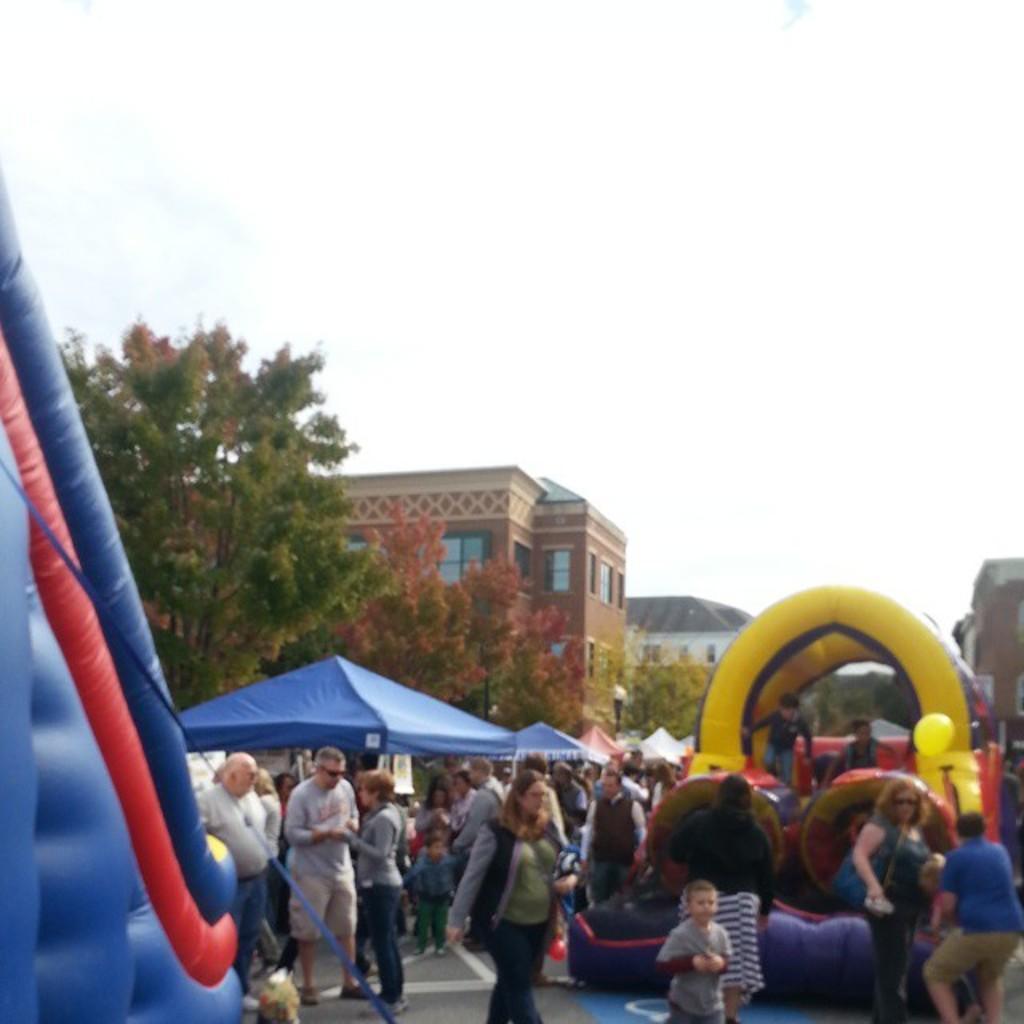Please provide a concise description of this image. In this image it looks like it is an exhibition in which there are so many tents, under which there are shops. There are so many people who are walking on the road while other are standing and talking with each other. On the left side there is a gas balloon. In the background there is a building. At the top there is the sky. On the left side there is a tree beside the building. On the right side there is a gas balloon on which there are fewer kids playing. 